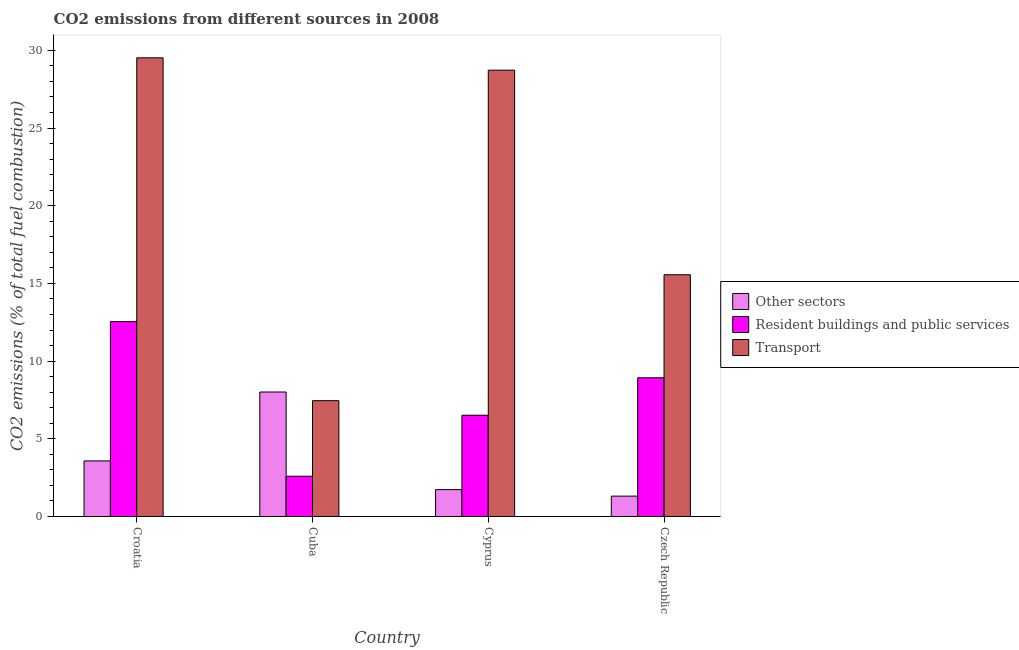How many different coloured bars are there?
Offer a very short reply. 3. Are the number of bars on each tick of the X-axis equal?
Keep it short and to the point. Yes. How many bars are there on the 3rd tick from the left?
Your response must be concise. 3. What is the label of the 3rd group of bars from the left?
Provide a short and direct response. Cyprus. In how many cases, is the number of bars for a given country not equal to the number of legend labels?
Make the answer very short. 0. What is the percentage of co2 emissions from other sectors in Cuba?
Offer a very short reply. 8.01. Across all countries, what is the maximum percentage of co2 emissions from other sectors?
Provide a short and direct response. 8.01. Across all countries, what is the minimum percentage of co2 emissions from other sectors?
Keep it short and to the point. 1.31. In which country was the percentage of co2 emissions from resident buildings and public services maximum?
Ensure brevity in your answer.  Croatia. In which country was the percentage of co2 emissions from transport minimum?
Your answer should be very brief. Cuba. What is the total percentage of co2 emissions from transport in the graph?
Provide a short and direct response. 81.25. What is the difference between the percentage of co2 emissions from other sectors in Cuba and that in Cyprus?
Ensure brevity in your answer.  6.28. What is the difference between the percentage of co2 emissions from other sectors in Croatia and the percentage of co2 emissions from resident buildings and public services in Czech Republic?
Provide a succinct answer. -5.35. What is the average percentage of co2 emissions from resident buildings and public services per country?
Ensure brevity in your answer.  7.64. What is the difference between the percentage of co2 emissions from resident buildings and public services and percentage of co2 emissions from other sectors in Croatia?
Provide a succinct answer. 8.97. What is the ratio of the percentage of co2 emissions from resident buildings and public services in Croatia to that in Czech Republic?
Ensure brevity in your answer.  1.4. Is the difference between the percentage of co2 emissions from other sectors in Cyprus and Czech Republic greater than the difference between the percentage of co2 emissions from transport in Cyprus and Czech Republic?
Offer a terse response. No. What is the difference between the highest and the second highest percentage of co2 emissions from resident buildings and public services?
Provide a succinct answer. 3.61. What is the difference between the highest and the lowest percentage of co2 emissions from resident buildings and public services?
Your answer should be very brief. 9.95. In how many countries, is the percentage of co2 emissions from transport greater than the average percentage of co2 emissions from transport taken over all countries?
Make the answer very short. 2. What does the 1st bar from the left in Cyprus represents?
Make the answer very short. Other sectors. What does the 3rd bar from the right in Cyprus represents?
Your response must be concise. Other sectors. How many bars are there?
Make the answer very short. 12. How many countries are there in the graph?
Keep it short and to the point. 4. Does the graph contain grids?
Offer a terse response. No. How are the legend labels stacked?
Provide a succinct answer. Vertical. What is the title of the graph?
Provide a succinct answer. CO2 emissions from different sources in 2008. What is the label or title of the X-axis?
Ensure brevity in your answer.  Country. What is the label or title of the Y-axis?
Give a very brief answer. CO2 emissions (% of total fuel combustion). What is the CO2 emissions (% of total fuel combustion) of Other sectors in Croatia?
Your response must be concise. 3.58. What is the CO2 emissions (% of total fuel combustion) in Resident buildings and public services in Croatia?
Provide a succinct answer. 12.54. What is the CO2 emissions (% of total fuel combustion) of Transport in Croatia?
Give a very brief answer. 29.52. What is the CO2 emissions (% of total fuel combustion) of Other sectors in Cuba?
Offer a terse response. 8.01. What is the CO2 emissions (% of total fuel combustion) in Resident buildings and public services in Cuba?
Your answer should be compact. 2.59. What is the CO2 emissions (% of total fuel combustion) in Transport in Cuba?
Your answer should be compact. 7.45. What is the CO2 emissions (% of total fuel combustion) in Other sectors in Cyprus?
Make the answer very short. 1.73. What is the CO2 emissions (% of total fuel combustion) of Resident buildings and public services in Cyprus?
Give a very brief answer. 6.52. What is the CO2 emissions (% of total fuel combustion) in Transport in Cyprus?
Offer a very short reply. 28.72. What is the CO2 emissions (% of total fuel combustion) in Other sectors in Czech Republic?
Provide a succinct answer. 1.31. What is the CO2 emissions (% of total fuel combustion) of Resident buildings and public services in Czech Republic?
Provide a succinct answer. 8.93. What is the CO2 emissions (% of total fuel combustion) in Transport in Czech Republic?
Offer a very short reply. 15.56. Across all countries, what is the maximum CO2 emissions (% of total fuel combustion) in Other sectors?
Your answer should be very brief. 8.01. Across all countries, what is the maximum CO2 emissions (% of total fuel combustion) of Resident buildings and public services?
Offer a very short reply. 12.54. Across all countries, what is the maximum CO2 emissions (% of total fuel combustion) in Transport?
Offer a terse response. 29.52. Across all countries, what is the minimum CO2 emissions (% of total fuel combustion) in Other sectors?
Your answer should be very brief. 1.31. Across all countries, what is the minimum CO2 emissions (% of total fuel combustion) of Resident buildings and public services?
Provide a short and direct response. 2.59. Across all countries, what is the minimum CO2 emissions (% of total fuel combustion) in Transport?
Provide a succinct answer. 7.45. What is the total CO2 emissions (% of total fuel combustion) of Other sectors in the graph?
Ensure brevity in your answer.  14.63. What is the total CO2 emissions (% of total fuel combustion) in Resident buildings and public services in the graph?
Give a very brief answer. 30.58. What is the total CO2 emissions (% of total fuel combustion) of Transport in the graph?
Your answer should be very brief. 81.25. What is the difference between the CO2 emissions (% of total fuel combustion) in Other sectors in Croatia and that in Cuba?
Your response must be concise. -4.43. What is the difference between the CO2 emissions (% of total fuel combustion) of Resident buildings and public services in Croatia and that in Cuba?
Your response must be concise. 9.95. What is the difference between the CO2 emissions (% of total fuel combustion) of Transport in Croatia and that in Cuba?
Provide a succinct answer. 22.07. What is the difference between the CO2 emissions (% of total fuel combustion) in Other sectors in Croatia and that in Cyprus?
Ensure brevity in your answer.  1.85. What is the difference between the CO2 emissions (% of total fuel combustion) in Resident buildings and public services in Croatia and that in Cyprus?
Offer a terse response. 6.03. What is the difference between the CO2 emissions (% of total fuel combustion) in Transport in Croatia and that in Cyprus?
Offer a very short reply. 0.8. What is the difference between the CO2 emissions (% of total fuel combustion) in Other sectors in Croatia and that in Czech Republic?
Your response must be concise. 2.27. What is the difference between the CO2 emissions (% of total fuel combustion) in Resident buildings and public services in Croatia and that in Czech Republic?
Your answer should be compact. 3.61. What is the difference between the CO2 emissions (% of total fuel combustion) in Transport in Croatia and that in Czech Republic?
Offer a very short reply. 13.96. What is the difference between the CO2 emissions (% of total fuel combustion) in Other sectors in Cuba and that in Cyprus?
Your response must be concise. 6.28. What is the difference between the CO2 emissions (% of total fuel combustion) in Resident buildings and public services in Cuba and that in Cyprus?
Your answer should be compact. -3.93. What is the difference between the CO2 emissions (% of total fuel combustion) in Transport in Cuba and that in Cyprus?
Your response must be concise. -21.27. What is the difference between the CO2 emissions (% of total fuel combustion) of Other sectors in Cuba and that in Czech Republic?
Make the answer very short. 6.7. What is the difference between the CO2 emissions (% of total fuel combustion) of Resident buildings and public services in Cuba and that in Czech Republic?
Your answer should be compact. -6.34. What is the difference between the CO2 emissions (% of total fuel combustion) in Transport in Cuba and that in Czech Republic?
Your answer should be compact. -8.1. What is the difference between the CO2 emissions (% of total fuel combustion) in Other sectors in Cyprus and that in Czech Republic?
Your answer should be compact. 0.42. What is the difference between the CO2 emissions (% of total fuel combustion) of Resident buildings and public services in Cyprus and that in Czech Republic?
Offer a very short reply. -2.41. What is the difference between the CO2 emissions (% of total fuel combustion) in Transport in Cyprus and that in Czech Republic?
Make the answer very short. 13.17. What is the difference between the CO2 emissions (% of total fuel combustion) in Other sectors in Croatia and the CO2 emissions (% of total fuel combustion) in Resident buildings and public services in Cuba?
Ensure brevity in your answer.  0.99. What is the difference between the CO2 emissions (% of total fuel combustion) of Other sectors in Croatia and the CO2 emissions (% of total fuel combustion) of Transport in Cuba?
Your answer should be very brief. -3.88. What is the difference between the CO2 emissions (% of total fuel combustion) in Resident buildings and public services in Croatia and the CO2 emissions (% of total fuel combustion) in Transport in Cuba?
Your answer should be compact. 5.09. What is the difference between the CO2 emissions (% of total fuel combustion) of Other sectors in Croatia and the CO2 emissions (% of total fuel combustion) of Resident buildings and public services in Cyprus?
Keep it short and to the point. -2.94. What is the difference between the CO2 emissions (% of total fuel combustion) in Other sectors in Croatia and the CO2 emissions (% of total fuel combustion) in Transport in Cyprus?
Your answer should be compact. -25.15. What is the difference between the CO2 emissions (% of total fuel combustion) in Resident buildings and public services in Croatia and the CO2 emissions (% of total fuel combustion) in Transport in Cyprus?
Ensure brevity in your answer.  -16.18. What is the difference between the CO2 emissions (% of total fuel combustion) of Other sectors in Croatia and the CO2 emissions (% of total fuel combustion) of Resident buildings and public services in Czech Republic?
Give a very brief answer. -5.35. What is the difference between the CO2 emissions (% of total fuel combustion) of Other sectors in Croatia and the CO2 emissions (% of total fuel combustion) of Transport in Czech Republic?
Offer a very short reply. -11.98. What is the difference between the CO2 emissions (% of total fuel combustion) of Resident buildings and public services in Croatia and the CO2 emissions (% of total fuel combustion) of Transport in Czech Republic?
Ensure brevity in your answer.  -3.01. What is the difference between the CO2 emissions (% of total fuel combustion) in Other sectors in Cuba and the CO2 emissions (% of total fuel combustion) in Resident buildings and public services in Cyprus?
Your answer should be very brief. 1.5. What is the difference between the CO2 emissions (% of total fuel combustion) of Other sectors in Cuba and the CO2 emissions (% of total fuel combustion) of Transport in Cyprus?
Your answer should be very brief. -20.71. What is the difference between the CO2 emissions (% of total fuel combustion) in Resident buildings and public services in Cuba and the CO2 emissions (% of total fuel combustion) in Transport in Cyprus?
Provide a succinct answer. -26.13. What is the difference between the CO2 emissions (% of total fuel combustion) of Other sectors in Cuba and the CO2 emissions (% of total fuel combustion) of Resident buildings and public services in Czech Republic?
Offer a very short reply. -0.92. What is the difference between the CO2 emissions (% of total fuel combustion) in Other sectors in Cuba and the CO2 emissions (% of total fuel combustion) in Transport in Czech Republic?
Provide a short and direct response. -7.54. What is the difference between the CO2 emissions (% of total fuel combustion) of Resident buildings and public services in Cuba and the CO2 emissions (% of total fuel combustion) of Transport in Czech Republic?
Make the answer very short. -12.97. What is the difference between the CO2 emissions (% of total fuel combustion) in Other sectors in Cyprus and the CO2 emissions (% of total fuel combustion) in Resident buildings and public services in Czech Republic?
Offer a terse response. -7.2. What is the difference between the CO2 emissions (% of total fuel combustion) in Other sectors in Cyprus and the CO2 emissions (% of total fuel combustion) in Transport in Czech Republic?
Offer a very short reply. -13.83. What is the difference between the CO2 emissions (% of total fuel combustion) in Resident buildings and public services in Cyprus and the CO2 emissions (% of total fuel combustion) in Transport in Czech Republic?
Keep it short and to the point. -9.04. What is the average CO2 emissions (% of total fuel combustion) in Other sectors per country?
Keep it short and to the point. 3.66. What is the average CO2 emissions (% of total fuel combustion) of Resident buildings and public services per country?
Give a very brief answer. 7.64. What is the average CO2 emissions (% of total fuel combustion) in Transport per country?
Your answer should be very brief. 20.31. What is the difference between the CO2 emissions (% of total fuel combustion) of Other sectors and CO2 emissions (% of total fuel combustion) of Resident buildings and public services in Croatia?
Make the answer very short. -8.97. What is the difference between the CO2 emissions (% of total fuel combustion) of Other sectors and CO2 emissions (% of total fuel combustion) of Transport in Croatia?
Keep it short and to the point. -25.94. What is the difference between the CO2 emissions (% of total fuel combustion) of Resident buildings and public services and CO2 emissions (% of total fuel combustion) of Transport in Croatia?
Provide a short and direct response. -16.98. What is the difference between the CO2 emissions (% of total fuel combustion) in Other sectors and CO2 emissions (% of total fuel combustion) in Resident buildings and public services in Cuba?
Your answer should be compact. 5.42. What is the difference between the CO2 emissions (% of total fuel combustion) of Other sectors and CO2 emissions (% of total fuel combustion) of Transport in Cuba?
Give a very brief answer. 0.56. What is the difference between the CO2 emissions (% of total fuel combustion) of Resident buildings and public services and CO2 emissions (% of total fuel combustion) of Transport in Cuba?
Your answer should be very brief. -4.86. What is the difference between the CO2 emissions (% of total fuel combustion) of Other sectors and CO2 emissions (% of total fuel combustion) of Resident buildings and public services in Cyprus?
Provide a succinct answer. -4.79. What is the difference between the CO2 emissions (% of total fuel combustion) of Other sectors and CO2 emissions (% of total fuel combustion) of Transport in Cyprus?
Provide a succinct answer. -26.99. What is the difference between the CO2 emissions (% of total fuel combustion) in Resident buildings and public services and CO2 emissions (% of total fuel combustion) in Transport in Cyprus?
Your answer should be compact. -22.21. What is the difference between the CO2 emissions (% of total fuel combustion) in Other sectors and CO2 emissions (% of total fuel combustion) in Resident buildings and public services in Czech Republic?
Your response must be concise. -7.62. What is the difference between the CO2 emissions (% of total fuel combustion) of Other sectors and CO2 emissions (% of total fuel combustion) of Transport in Czech Republic?
Your answer should be very brief. -14.25. What is the difference between the CO2 emissions (% of total fuel combustion) in Resident buildings and public services and CO2 emissions (% of total fuel combustion) in Transport in Czech Republic?
Keep it short and to the point. -6.63. What is the ratio of the CO2 emissions (% of total fuel combustion) in Other sectors in Croatia to that in Cuba?
Provide a short and direct response. 0.45. What is the ratio of the CO2 emissions (% of total fuel combustion) in Resident buildings and public services in Croatia to that in Cuba?
Make the answer very short. 4.84. What is the ratio of the CO2 emissions (% of total fuel combustion) of Transport in Croatia to that in Cuba?
Your answer should be compact. 3.96. What is the ratio of the CO2 emissions (% of total fuel combustion) in Other sectors in Croatia to that in Cyprus?
Your answer should be compact. 2.07. What is the ratio of the CO2 emissions (% of total fuel combustion) in Resident buildings and public services in Croatia to that in Cyprus?
Your answer should be very brief. 1.92. What is the ratio of the CO2 emissions (% of total fuel combustion) of Transport in Croatia to that in Cyprus?
Keep it short and to the point. 1.03. What is the ratio of the CO2 emissions (% of total fuel combustion) of Other sectors in Croatia to that in Czech Republic?
Offer a very short reply. 2.73. What is the ratio of the CO2 emissions (% of total fuel combustion) in Resident buildings and public services in Croatia to that in Czech Republic?
Provide a short and direct response. 1.4. What is the ratio of the CO2 emissions (% of total fuel combustion) of Transport in Croatia to that in Czech Republic?
Provide a succinct answer. 1.9. What is the ratio of the CO2 emissions (% of total fuel combustion) of Other sectors in Cuba to that in Cyprus?
Offer a very short reply. 4.63. What is the ratio of the CO2 emissions (% of total fuel combustion) of Resident buildings and public services in Cuba to that in Cyprus?
Your answer should be compact. 0.4. What is the ratio of the CO2 emissions (% of total fuel combustion) of Transport in Cuba to that in Cyprus?
Offer a very short reply. 0.26. What is the ratio of the CO2 emissions (% of total fuel combustion) of Other sectors in Cuba to that in Czech Republic?
Offer a very short reply. 6.11. What is the ratio of the CO2 emissions (% of total fuel combustion) of Resident buildings and public services in Cuba to that in Czech Republic?
Your answer should be very brief. 0.29. What is the ratio of the CO2 emissions (% of total fuel combustion) of Transport in Cuba to that in Czech Republic?
Provide a short and direct response. 0.48. What is the ratio of the CO2 emissions (% of total fuel combustion) of Other sectors in Cyprus to that in Czech Republic?
Provide a short and direct response. 1.32. What is the ratio of the CO2 emissions (% of total fuel combustion) in Resident buildings and public services in Cyprus to that in Czech Republic?
Keep it short and to the point. 0.73. What is the ratio of the CO2 emissions (% of total fuel combustion) in Transport in Cyprus to that in Czech Republic?
Offer a very short reply. 1.85. What is the difference between the highest and the second highest CO2 emissions (% of total fuel combustion) in Other sectors?
Your response must be concise. 4.43. What is the difference between the highest and the second highest CO2 emissions (% of total fuel combustion) in Resident buildings and public services?
Make the answer very short. 3.61. What is the difference between the highest and the second highest CO2 emissions (% of total fuel combustion) in Transport?
Give a very brief answer. 0.8. What is the difference between the highest and the lowest CO2 emissions (% of total fuel combustion) of Other sectors?
Ensure brevity in your answer.  6.7. What is the difference between the highest and the lowest CO2 emissions (% of total fuel combustion) in Resident buildings and public services?
Offer a very short reply. 9.95. What is the difference between the highest and the lowest CO2 emissions (% of total fuel combustion) of Transport?
Your answer should be very brief. 22.07. 